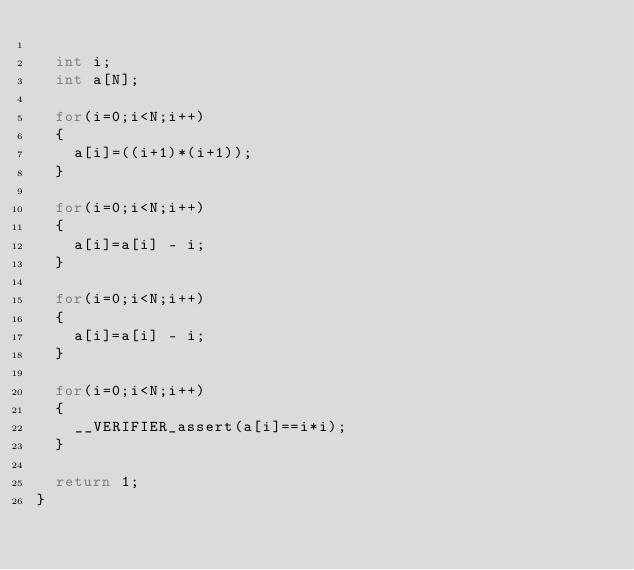<code> <loc_0><loc_0><loc_500><loc_500><_C_>
	int i;
	int a[N];

	for(i=0;i<N;i++)
	{
		a[i]=((i+1)*(i+1));
	}

	for(i=0;i<N;i++)
	{
		a[i]=a[i] - i;
	}

	for(i=0;i<N;i++)
	{
		a[i]=a[i] - i;
	}

	for(i=0;i<N;i++)
	{
		__VERIFIER_assert(a[i]==i*i);
	}

	return 1;
}
</code> 